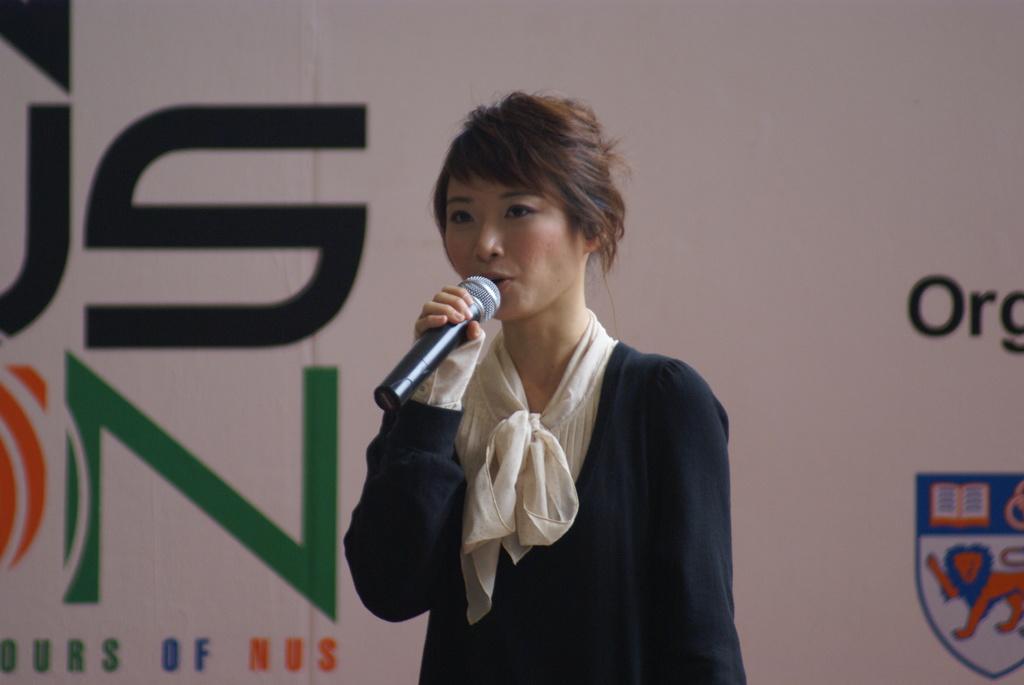Can you describe this image briefly? In the picture we can see a woman standing and talking in the microphone holding it, behind her we can see a banner. 